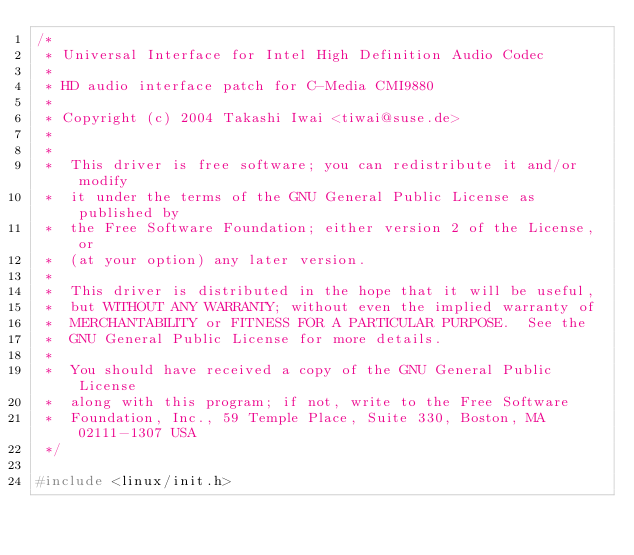<code> <loc_0><loc_0><loc_500><loc_500><_C_>/*
 * Universal Interface for Intel High Definition Audio Codec
 *
 * HD audio interface patch for C-Media CMI9880
 *
 * Copyright (c) 2004 Takashi Iwai <tiwai@suse.de>
 *
 *
 *  This driver is free software; you can redistribute it and/or modify
 *  it under the terms of the GNU General Public License as published by
 *  the Free Software Foundation; either version 2 of the License, or
 *  (at your option) any later version.
 *
 *  This driver is distributed in the hope that it will be useful,
 *  but WITHOUT ANY WARRANTY; without even the implied warranty of
 *  MERCHANTABILITY or FITNESS FOR A PARTICULAR PURPOSE.  See the
 *  GNU General Public License for more details.
 *
 *  You should have received a copy of the GNU General Public License
 *  along with this program; if not, write to the Free Software
 *  Foundation, Inc., 59 Temple Place, Suite 330, Boston, MA  02111-1307 USA
 */

#include <linux/init.h></code> 